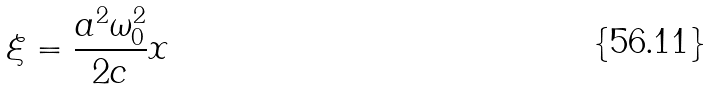<formula> <loc_0><loc_0><loc_500><loc_500>\xi = \frac { a ^ { 2 } \omega _ { 0 } ^ { 2 } } { 2 c } x</formula> 